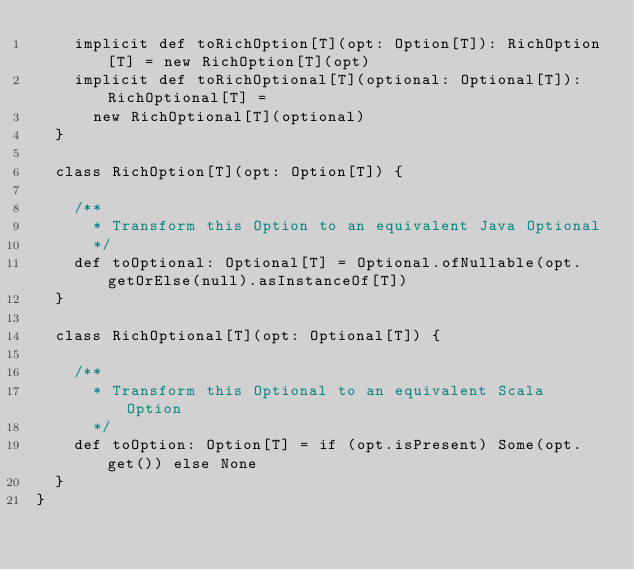<code> <loc_0><loc_0><loc_500><loc_500><_Scala_>    implicit def toRichOption[T](opt: Option[T]): RichOption[T] = new RichOption[T](opt)
    implicit def toRichOptional[T](optional: Optional[T]): RichOptional[T] =
      new RichOptional[T](optional)
  }

  class RichOption[T](opt: Option[T]) {

    /**
      * Transform this Option to an equivalent Java Optional
      */
    def toOptional: Optional[T] = Optional.ofNullable(opt.getOrElse(null).asInstanceOf[T])
  }

  class RichOptional[T](opt: Optional[T]) {

    /**
      * Transform this Optional to an equivalent Scala Option
      */
    def toOption: Option[T] = if (opt.isPresent) Some(opt.get()) else None
  }
}
</code> 